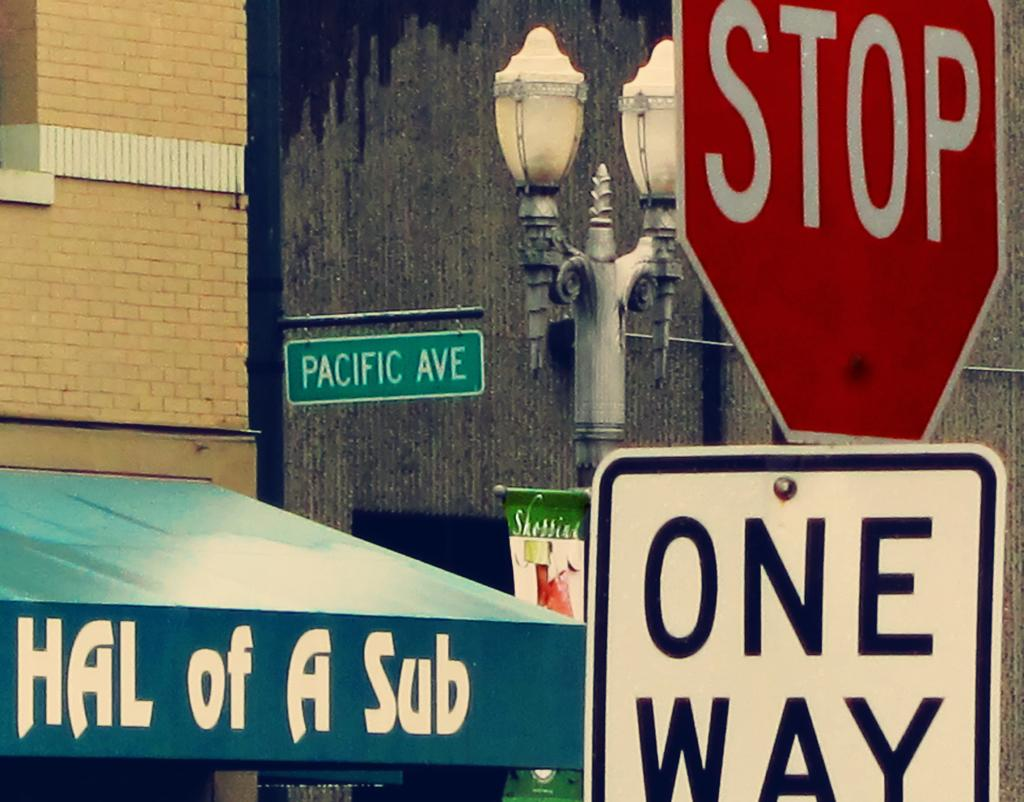<image>
Create a compact narrative representing the image presented. A Stop and One Way sign in the foreground with a Pacific Ave sign in the background. 